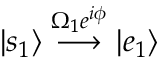Convert formula to latex. <formula><loc_0><loc_0><loc_500><loc_500>| s _ { 1 } \rangle \stackrel { \Omega _ { 1 } e ^ { i \phi } } { \longrightarrow } | e _ { 1 } \rangle</formula> 